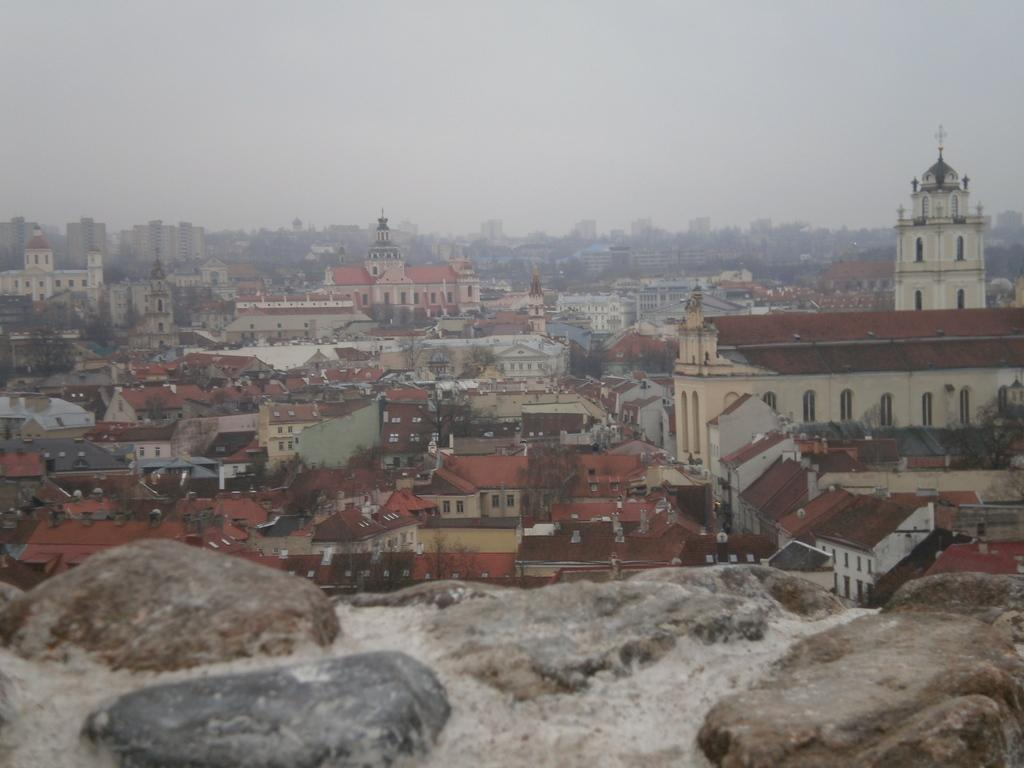What type of structures can be seen in the image? There are buildings in the image. What other natural elements are present in the image? There are trees in the image. What is located in the foreground of the image? There are stones in the foreground of the image. What is visible at the top of the image? The sky is visible at the top of the image. Can you tell me how many feet are visible in the image? There are no feet present in the image; it features buildings, trees, stones, and the sky. What type of teaching is taking place in the image? There is no teaching activity depicted in the image. 